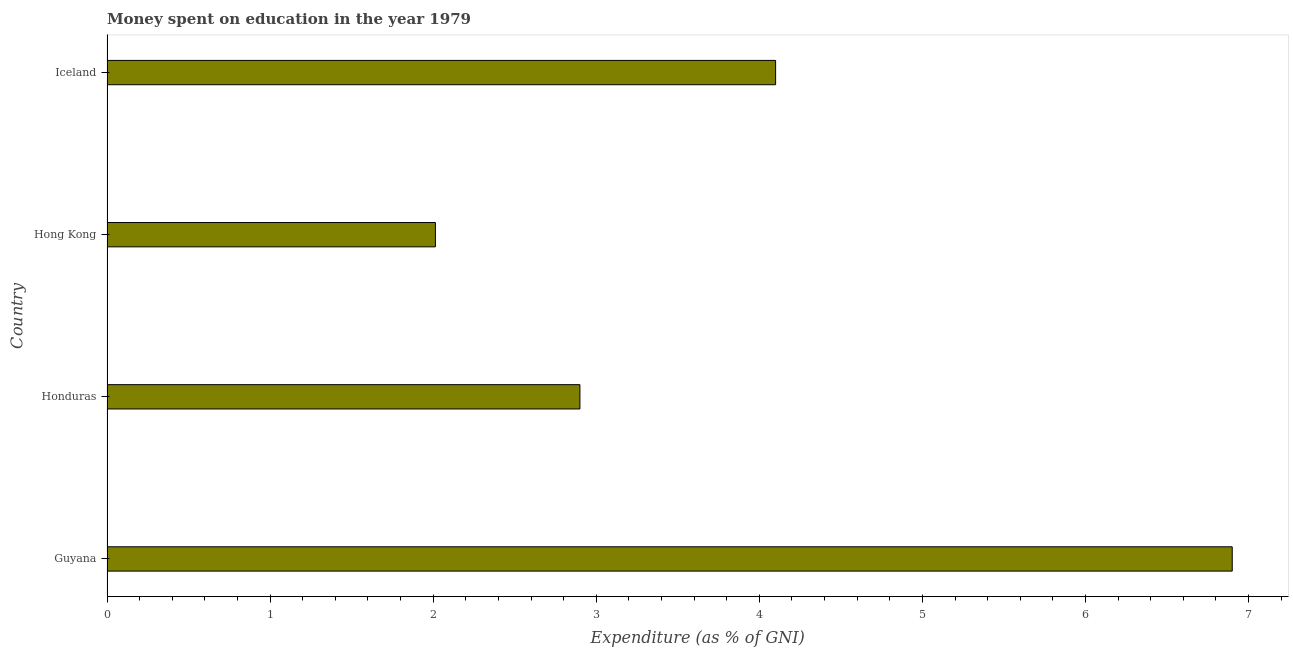Does the graph contain any zero values?
Your response must be concise. No. What is the title of the graph?
Ensure brevity in your answer.  Money spent on education in the year 1979. What is the label or title of the X-axis?
Offer a terse response. Expenditure (as % of GNI). Across all countries, what is the maximum expenditure on education?
Make the answer very short. 6.9. Across all countries, what is the minimum expenditure on education?
Make the answer very short. 2.01. In which country was the expenditure on education maximum?
Keep it short and to the point. Guyana. In which country was the expenditure on education minimum?
Give a very brief answer. Hong Kong. What is the sum of the expenditure on education?
Make the answer very short. 15.91. What is the difference between the expenditure on education in Guyana and Iceland?
Offer a terse response. 2.8. What is the average expenditure on education per country?
Offer a terse response. 3.98. What is the ratio of the expenditure on education in Guyana to that in Hong Kong?
Offer a terse response. 3.43. Is the difference between the expenditure on education in Hong Kong and Iceland greater than the difference between any two countries?
Your answer should be compact. No. What is the difference between the highest and the second highest expenditure on education?
Keep it short and to the point. 2.8. Is the sum of the expenditure on education in Guyana and Iceland greater than the maximum expenditure on education across all countries?
Offer a terse response. Yes. What is the difference between the highest and the lowest expenditure on education?
Offer a very short reply. 4.89. How many bars are there?
Provide a short and direct response. 4. Are all the bars in the graph horizontal?
Give a very brief answer. Yes. How many countries are there in the graph?
Provide a short and direct response. 4. What is the difference between two consecutive major ticks on the X-axis?
Provide a short and direct response. 1. Are the values on the major ticks of X-axis written in scientific E-notation?
Give a very brief answer. No. What is the Expenditure (as % of GNI) of Honduras?
Provide a short and direct response. 2.9. What is the Expenditure (as % of GNI) in Hong Kong?
Your response must be concise. 2.01. What is the difference between the Expenditure (as % of GNI) in Guyana and Hong Kong?
Make the answer very short. 4.89. What is the difference between the Expenditure (as % of GNI) in Guyana and Iceland?
Ensure brevity in your answer.  2.8. What is the difference between the Expenditure (as % of GNI) in Honduras and Hong Kong?
Provide a succinct answer. 0.89. What is the difference between the Expenditure (as % of GNI) in Hong Kong and Iceland?
Offer a very short reply. -2.09. What is the ratio of the Expenditure (as % of GNI) in Guyana to that in Honduras?
Offer a terse response. 2.38. What is the ratio of the Expenditure (as % of GNI) in Guyana to that in Hong Kong?
Offer a very short reply. 3.43. What is the ratio of the Expenditure (as % of GNI) in Guyana to that in Iceland?
Ensure brevity in your answer.  1.68. What is the ratio of the Expenditure (as % of GNI) in Honduras to that in Hong Kong?
Provide a short and direct response. 1.44. What is the ratio of the Expenditure (as % of GNI) in Honduras to that in Iceland?
Your answer should be compact. 0.71. What is the ratio of the Expenditure (as % of GNI) in Hong Kong to that in Iceland?
Give a very brief answer. 0.49. 